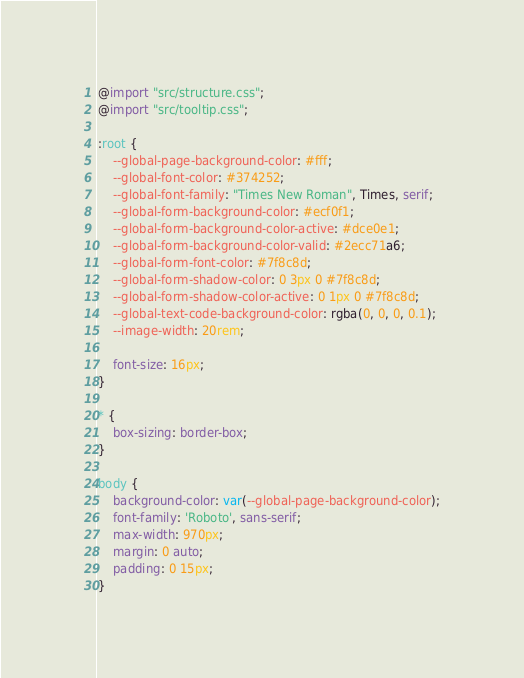Convert code to text. <code><loc_0><loc_0><loc_500><loc_500><_CSS_>@import "src/structure.css";
@import "src/tooltip.css";

:root {
    --global-page-background-color: #fff;
    --global-font-color: #374252;
    --global-font-family: "Times New Roman", Times, serif;
    --global-form-background-color: #ecf0f1;
    --global-form-background-color-active: #dce0e1;
    --global-form-background-color-valid: #2ecc71a6;
    --global-form-font-color: #7f8c8d;
    --global-form-shadow-color: 0 3px 0 #7f8c8d;
    --global-form-shadow-color-active: 0 1px 0 #7f8c8d;
    --global-text-code-background-color: rgba(0, 0, 0, 0.1);
    --image-width: 20rem;

    font-size: 16px;
}

* {
    box-sizing: border-box;
}

body {
    background-color: var(--global-page-background-color);
    font-family: 'Roboto', sans-serif;
    max-width: 970px;
    margin: 0 auto;
    padding: 0 15px;
}
</code> 